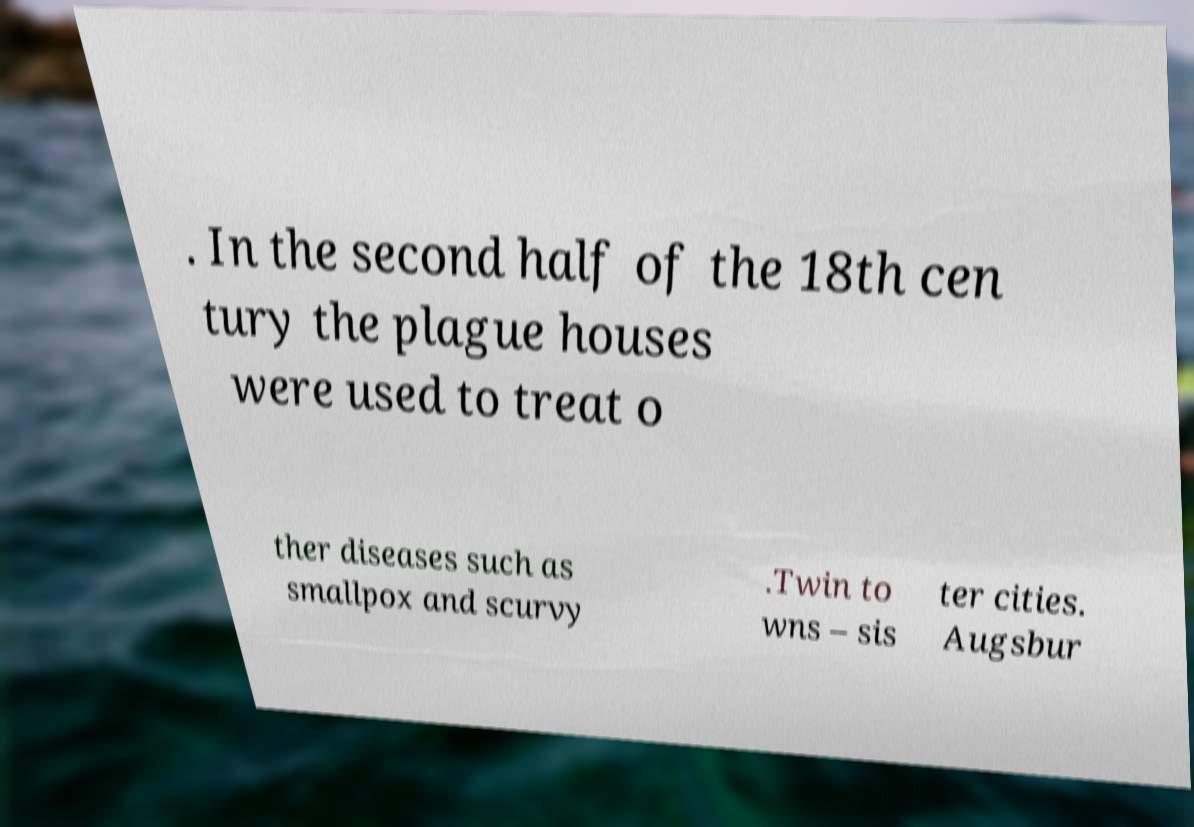Could you assist in decoding the text presented in this image and type it out clearly? . In the second half of the 18th cen tury the plague houses were used to treat o ther diseases such as smallpox and scurvy .Twin to wns – sis ter cities. Augsbur 